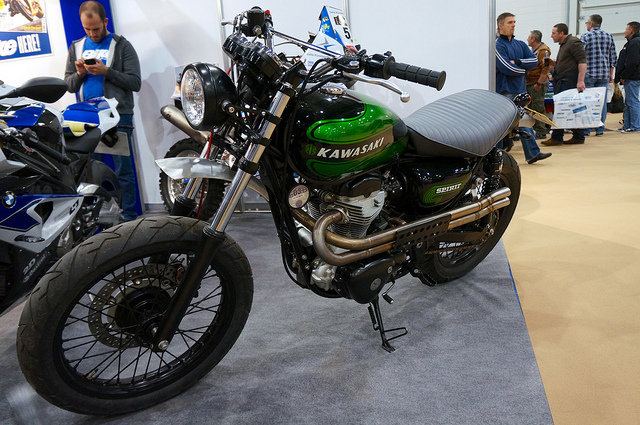Identify the text displayed in this image. KAWASAKI S 